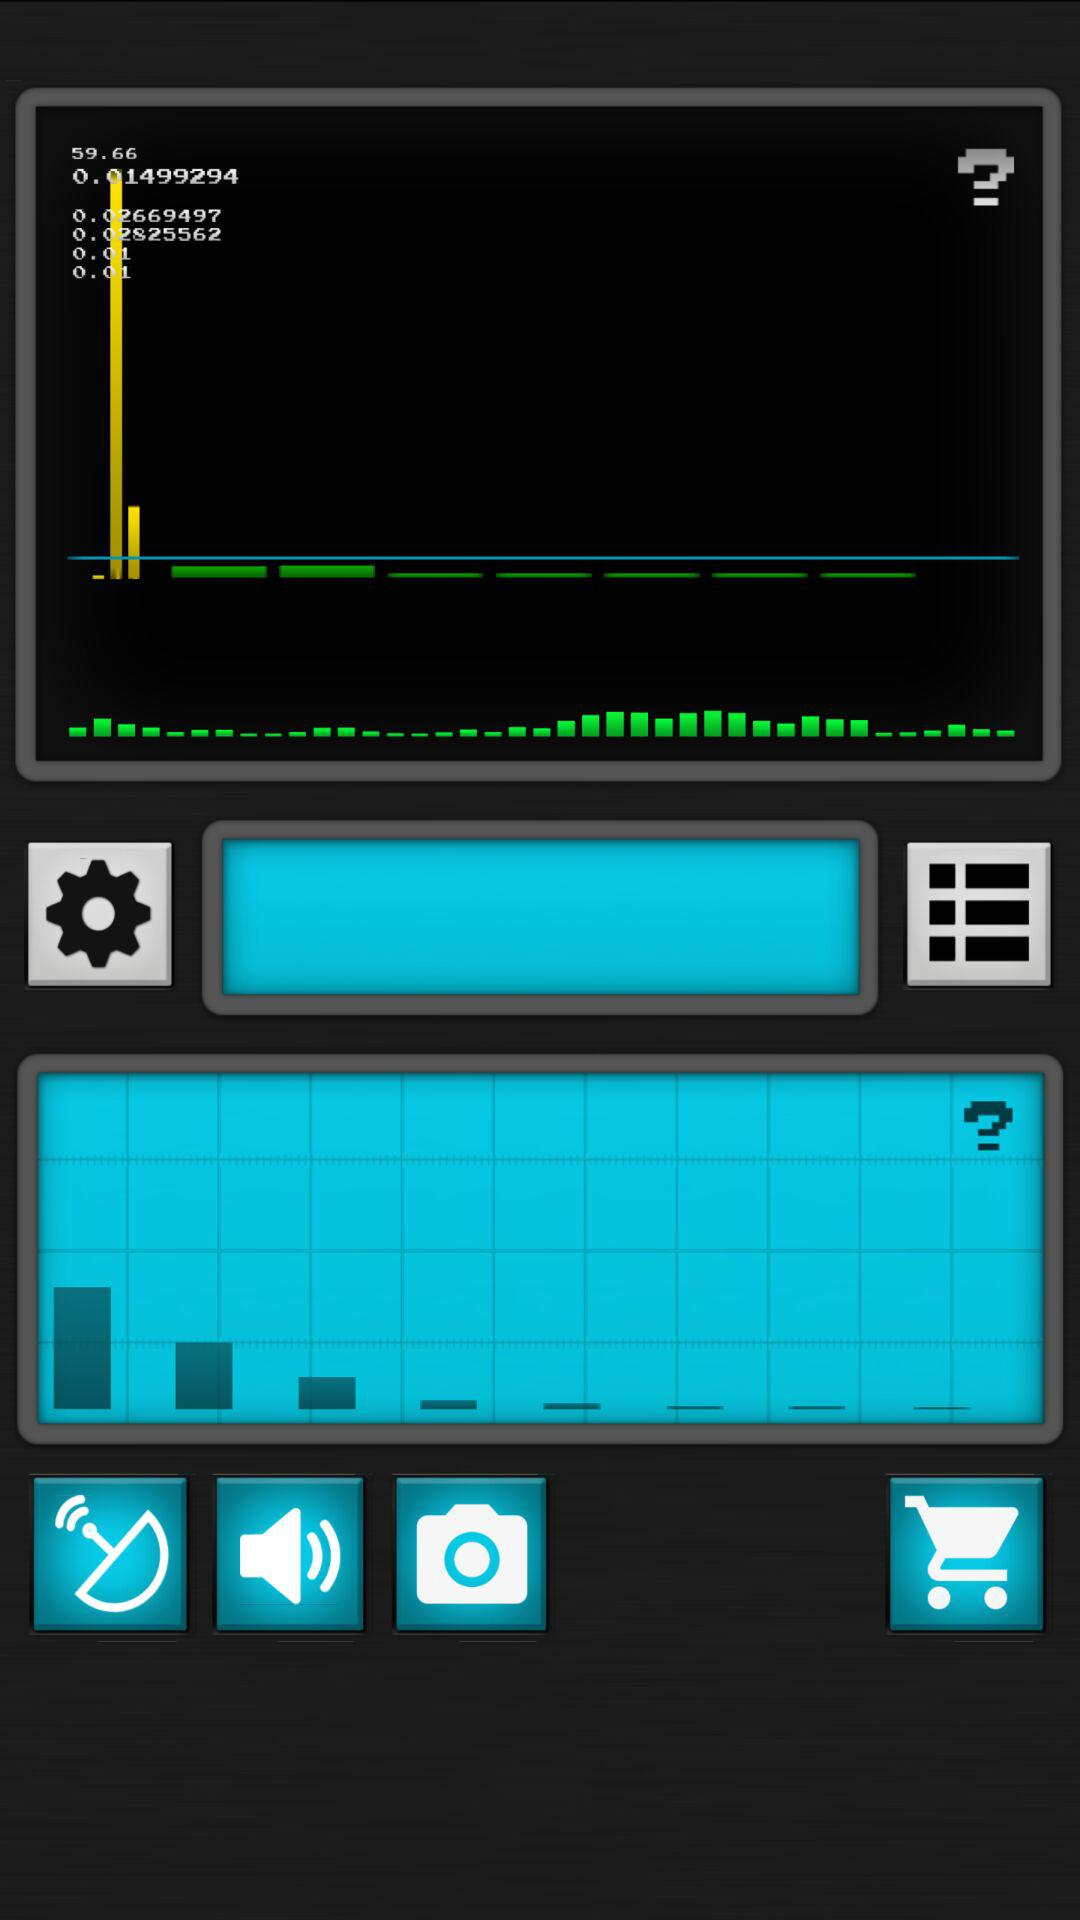How much higher is the number 59.66 compared to the number 50?
Answer the question using a single word or phrase. 9.66 